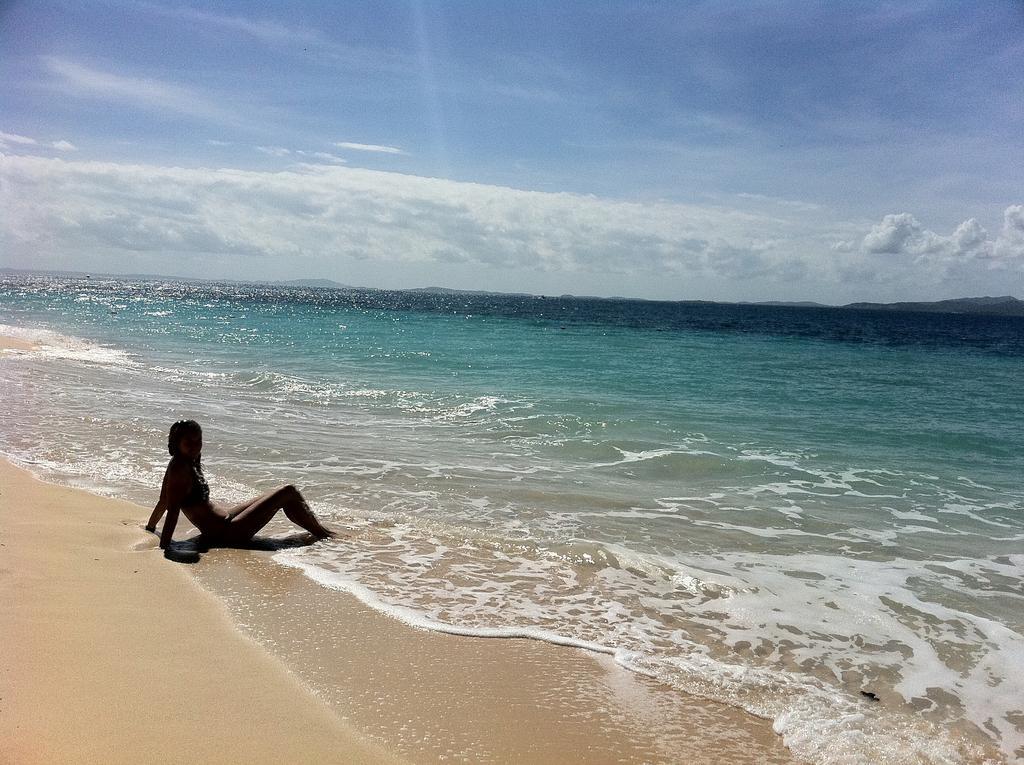Could you give a brief overview of what you see in this image? In the picture I can see a person is sitting on the ground. In the background I can see the water and the sky. 